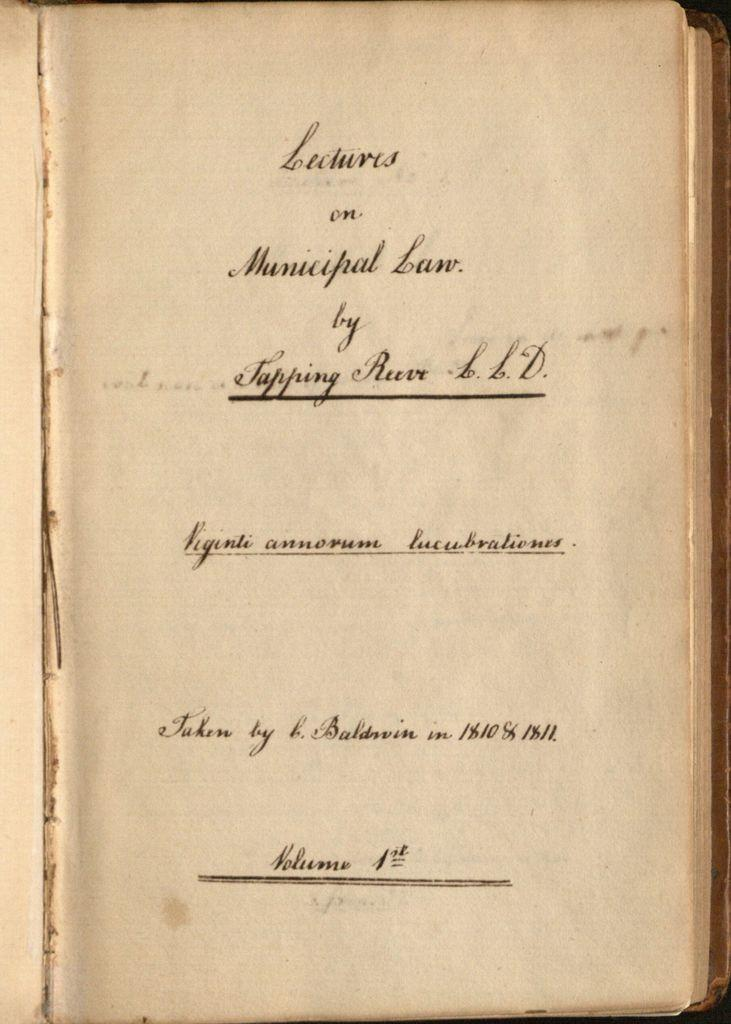<image>
Provide a brief description of the given image. The inside of an old book that says on the front page Lectures on Municipal Law. 